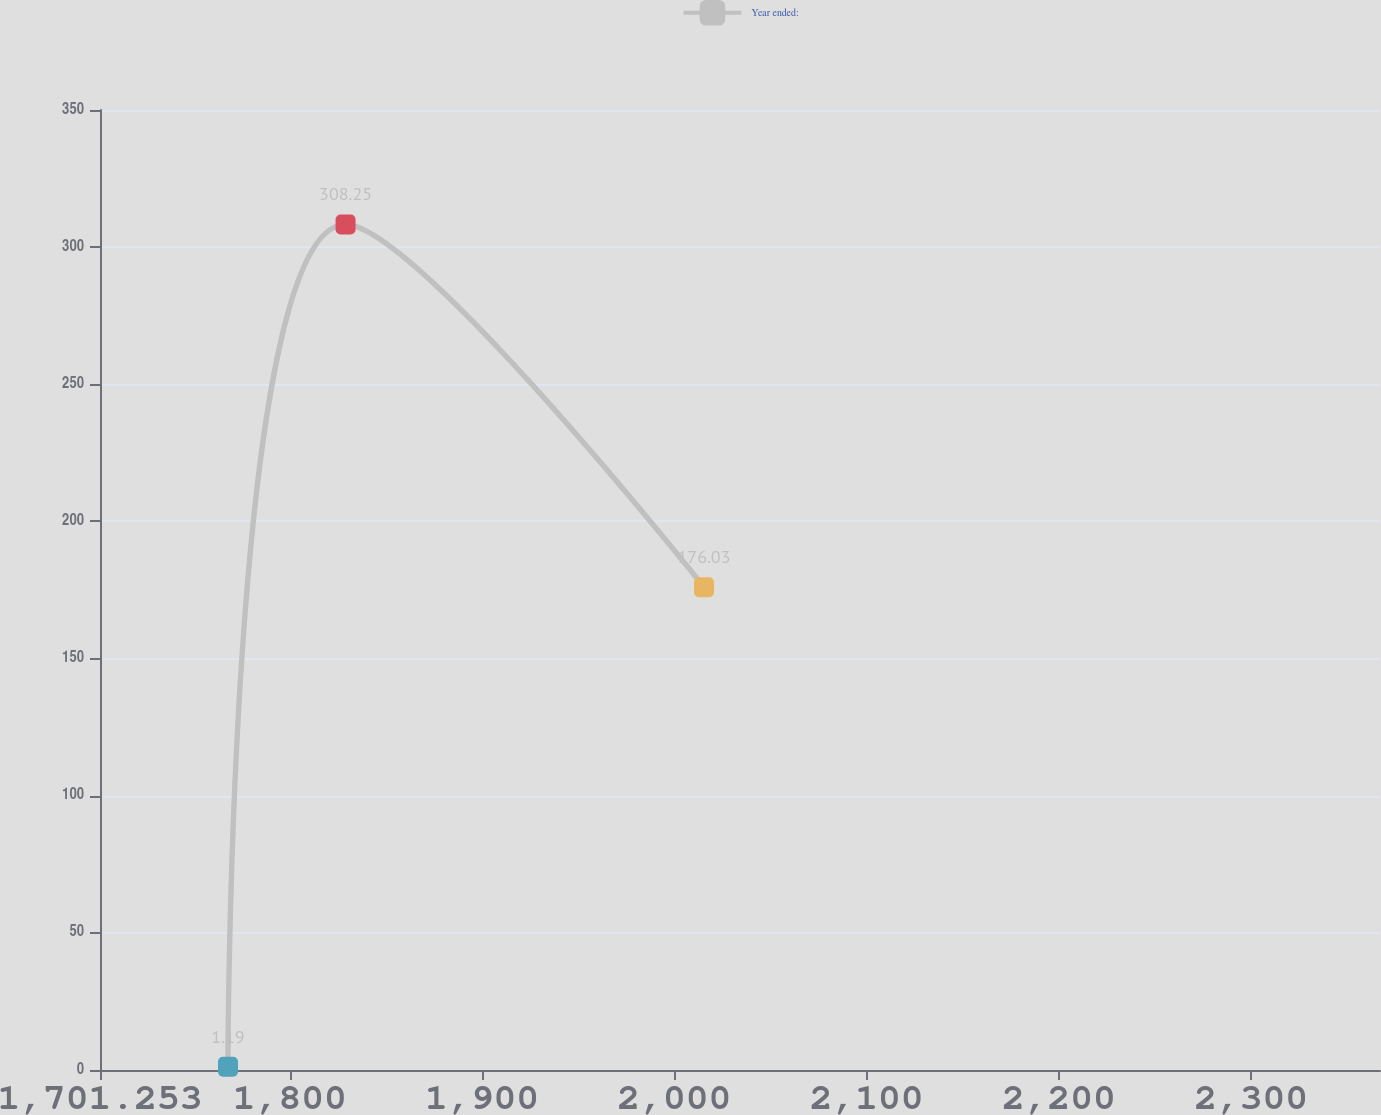Convert chart. <chart><loc_0><loc_0><loc_500><loc_500><line_chart><ecel><fcel>Year ended:<nl><fcel>1767.83<fcel>1.19<nl><fcel>1828.98<fcel>308.25<nl><fcel>2015.42<fcel>176.03<nl><fcel>2372.45<fcel>31.09<nl><fcel>2433.6<fcel>278.35<nl></chart> 